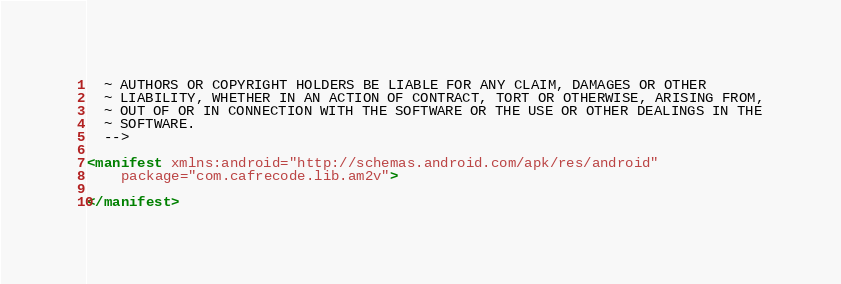<code> <loc_0><loc_0><loc_500><loc_500><_XML_>  ~ AUTHORS OR COPYRIGHT HOLDERS BE LIABLE FOR ANY CLAIM, DAMAGES OR OTHER
  ~ LIABILITY, WHETHER IN AN ACTION OF CONTRACT, TORT OR OTHERWISE, ARISING FROM,
  ~ OUT OF OR IN CONNECTION WITH THE SOFTWARE OR THE USE OR OTHER DEALINGS IN THE
  ~ SOFTWARE.
  -->

<manifest xmlns:android="http://schemas.android.com/apk/res/android"
    package="com.cafrecode.lib.am2v">

</manifest></code> 